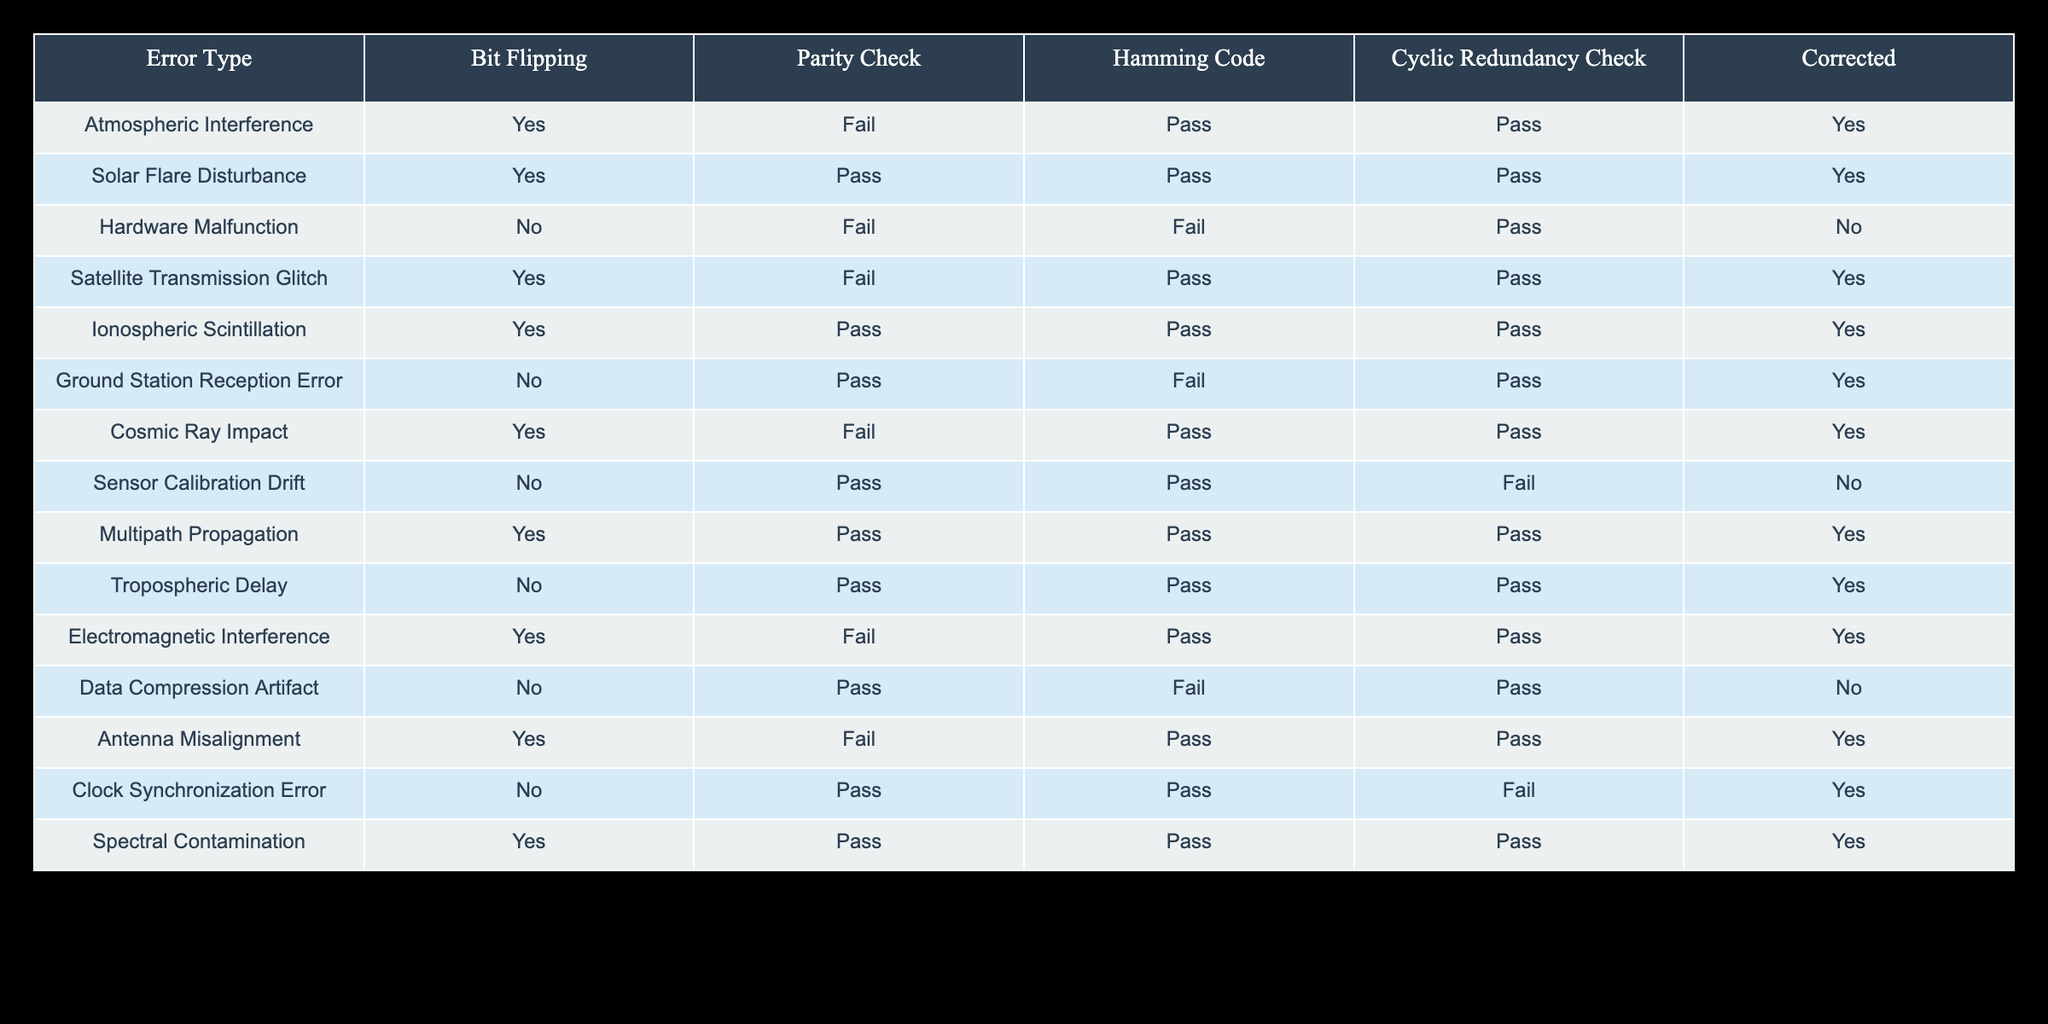What types of errors can be detected or corrected by Hamming Code? By examining the "Hamming Code" column, we look for entries marked as "Pass" which indicates that the error type can be detected or corrected by Hamming Code. The errors listed with "Pass" are: Solar Flare Disturbance, Satellite Transmission Glitch, Ionospheric Scintillation, Cosmic Ray Impact, Antenna Misalignment, and Spectral Contamination.
Answer: 6 types Which error type is detected by Parity Check but not corrected by Hamming Code? We need to look for entries where "Parity Check" is marked as "Pass" and "Hamming Code" is marked as "Fail." The only entry that meets these criteria is the "Ground Station Reception Error."
Answer: Ground Station Reception Error How many errors can be both detected and corrected by at least one method? We check each method and count the unique error types where any of the detection methods (Bit Flipping, Parity Check, Hamming Code, Cyclic Redundancy Check) are marked as "Pass" for corrections. The errors with at least one "Pass" are: Atmospheric Interference, Solar Flare Disturbance, Hardware Malfunction, Satellite Transmission Glitch, Ionospheric Scintillation, Ground Station Reception Error, Cosmic Ray Impact, Multipath Propagation, Tropospheric Delay, Electromagnetic Interference, Antenna Misalignment, Clock Synchronization Error, and Spectral Contamination, totaling 13 unique errors.
Answer: 13 Are any of the error types corrected by Cyclic Redundancy Check but not by Hamming Code? We identify the errors where "Cyclic Redundancy Check" is marked as "Pass," and "Hamming Code" is marked as "Fail." The only entry that fits this description is "Hardware Malfunction."
Answer: Yes, Hardware Malfunction Which error was affected by Bit Flipping and also passed Parity Check? We look for the "Bit Flipping" column marked "Yes" along with the "Parity Check" column marked "Pass." The errors that meet these criteria are Solar Flare Disturbance, Ionospheric Scintillation, Multipath Propagation, and Spectral Contamination.
Answer: 4 errors: Solar Flare Disturbance, Ionospheric Scintillation, Multipath Propagation, Spectral Contamination 